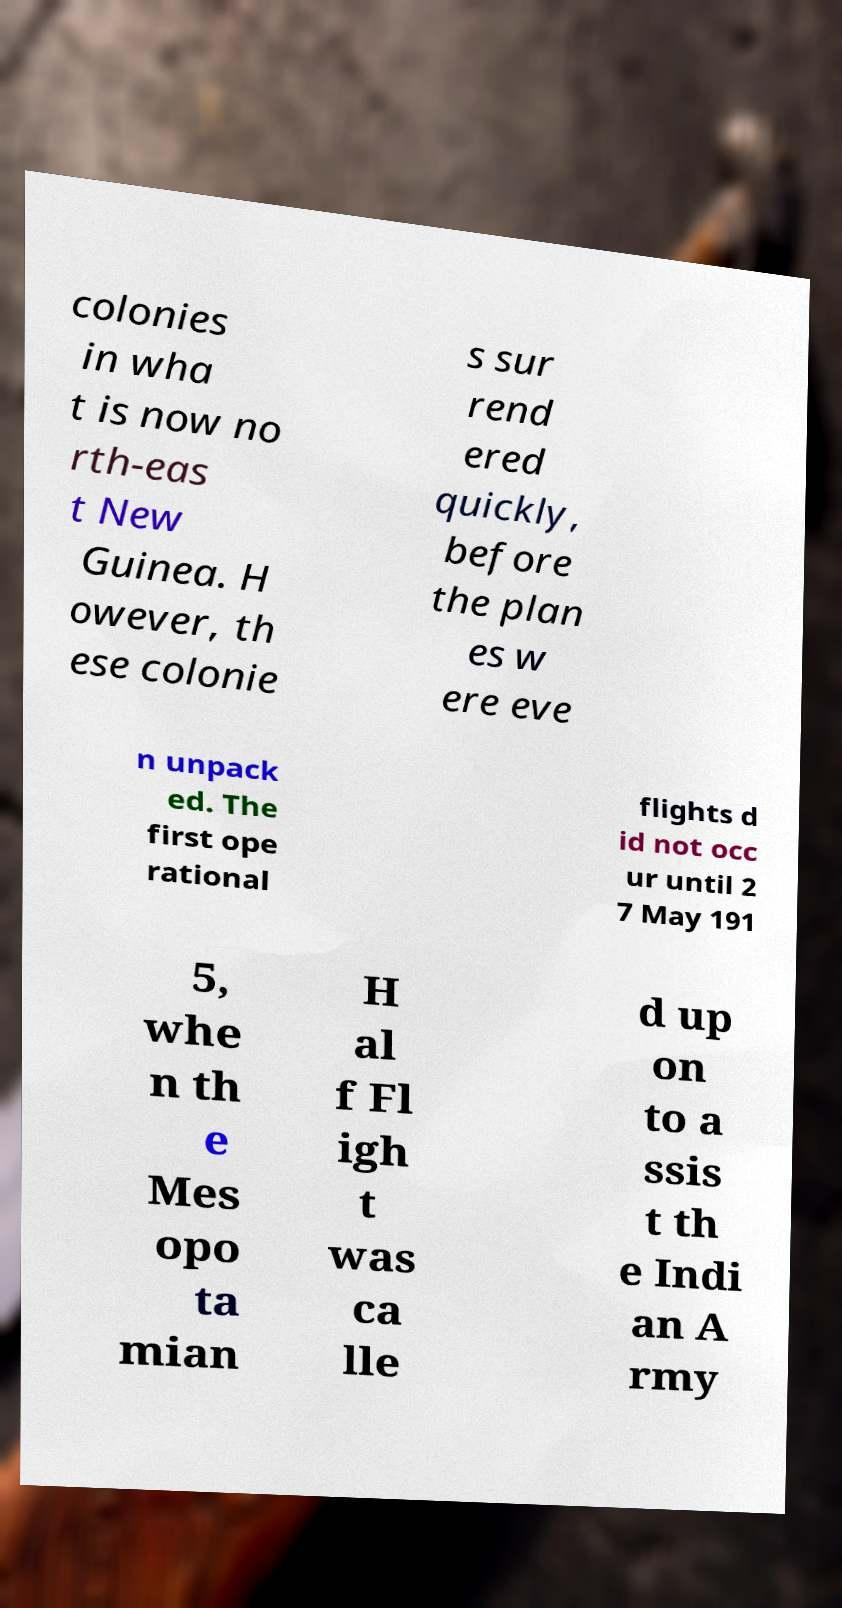Please read and relay the text visible in this image. What does it say? colonies in wha t is now no rth-eas t New Guinea. H owever, th ese colonie s sur rend ered quickly, before the plan es w ere eve n unpack ed. The first ope rational flights d id not occ ur until 2 7 May 191 5, whe n th e Mes opo ta mian H al f Fl igh t was ca lle d up on to a ssis t th e Indi an A rmy 